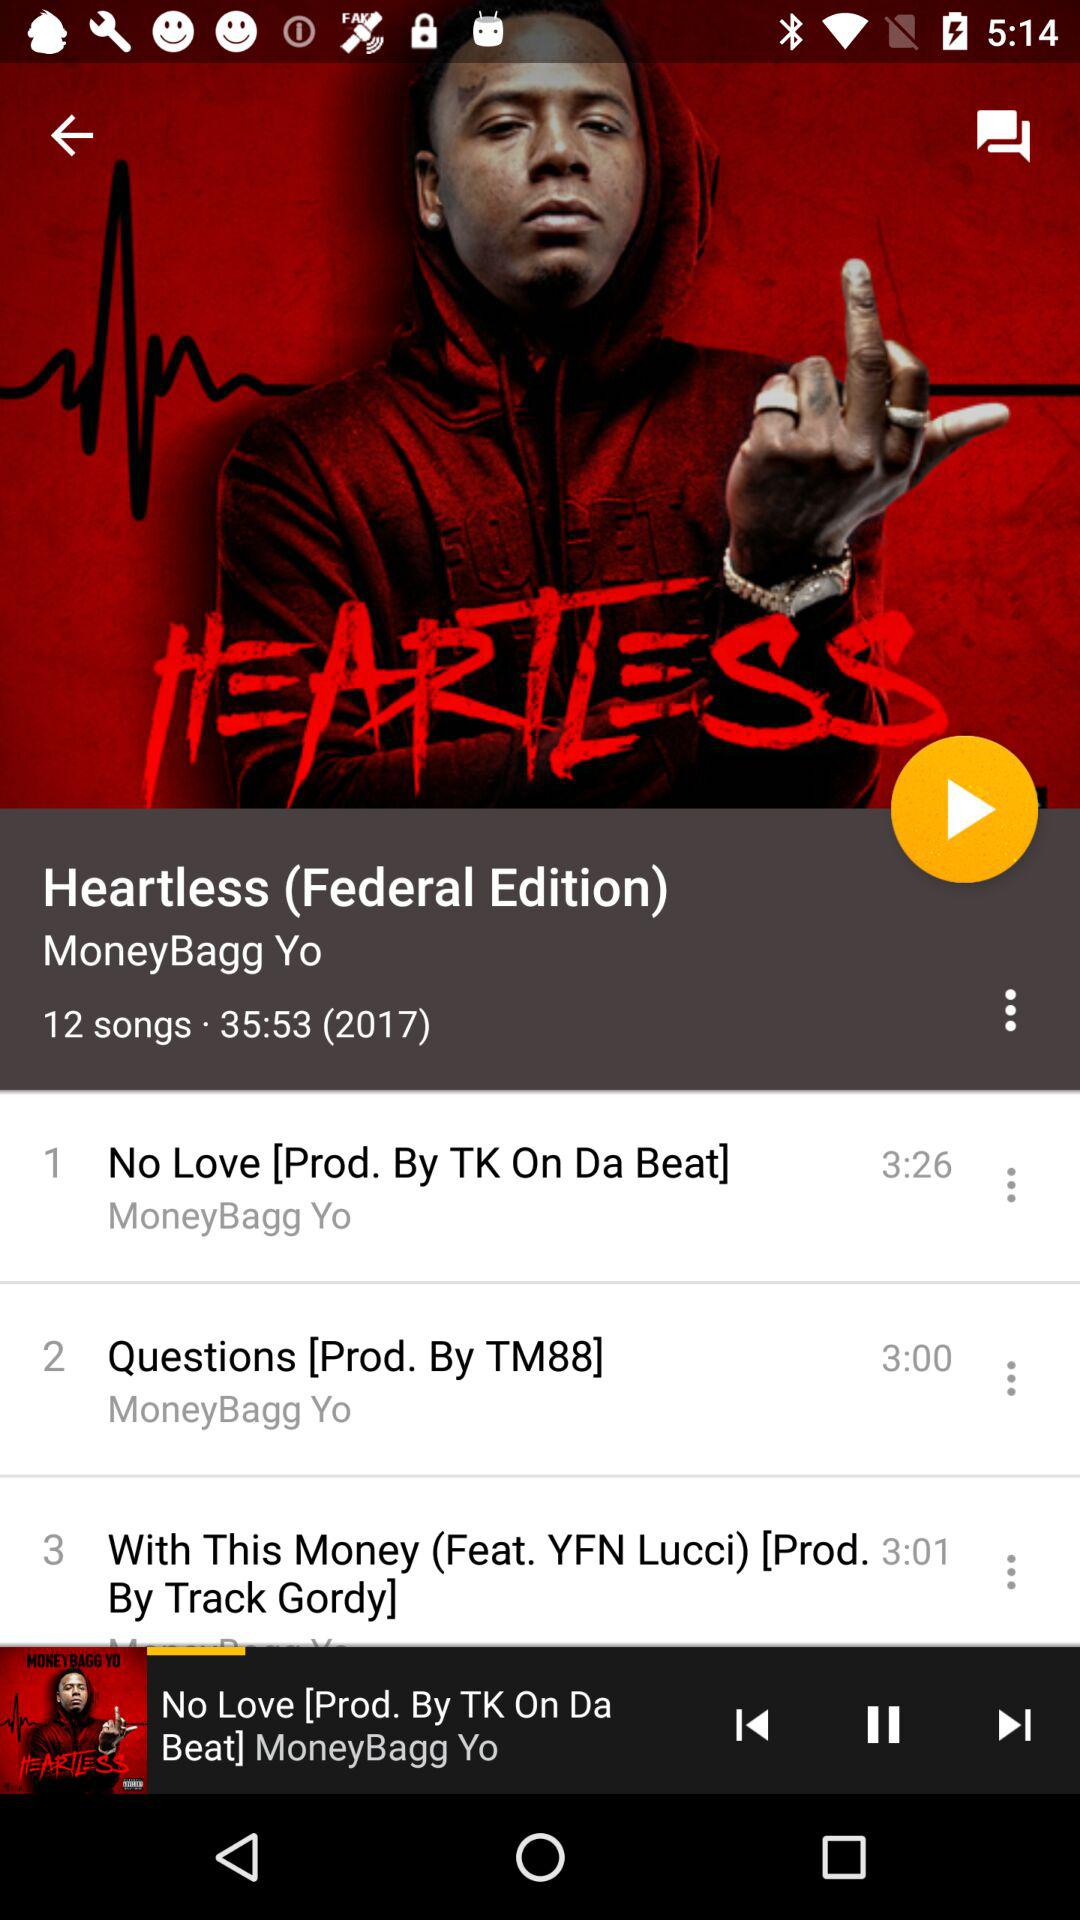What is the length of the song "Questions [Prod. By TM88]"? The length of the song is 3 minutes. 